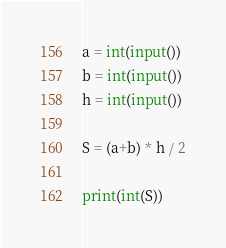<code> <loc_0><loc_0><loc_500><loc_500><_Python_>a = int(input())
b = int(input())
h = int(input())

S = (a+b) * h / 2

print(int(S))
</code> 